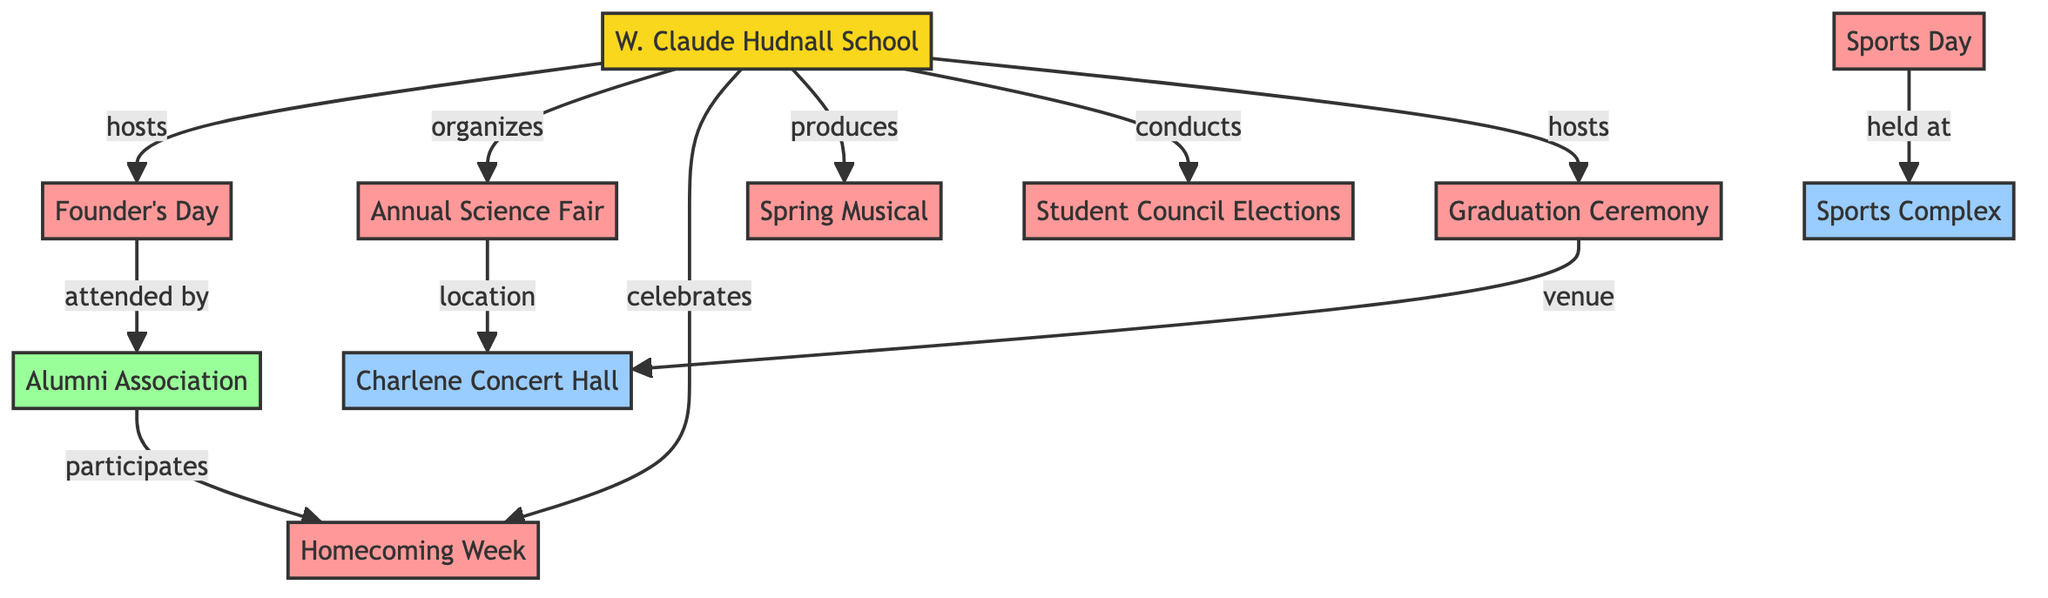What is the location of the Annual Science Fair? The Annual Science Fair is linked to Charlene Concert Hall by the "location" edge. Following this edge from node 3 (Annual Science Fair) leads to node 8 (Charlene Concert Hall)
Answer: Charlene Concert Hall Which event does W. Claude Hudnall School celebrate? The diagram shows a connection labeled "celebrates" from node 1 (W. Claude Hudnall School) to node 4 (Homecoming Week). This indicates that W. Claude Hudnall School celebrates Homecoming Week
Answer: Homecoming Week How many nodes are in the diagram? The diagram lists a total of 11 unique nodes representing different events, locations, and organizations. Counting each one gives us the total
Answer: 11 What type of event does the Alumni Association participate in? The Alumni Association participates in events that are linked to node 4 (Homecoming Week) by the "participates" edge from node 10 (Alumni Association)
Answer: Homecoming Week What is the connection type between Sports Day and Sports Complex? The relationship is defined by the edge labeled "held at," which connects node 6 (Sports Day) to node 9 (Sports Complex). This means Sports Day is held at the Sports Complex
Answer: held at Who attends Founder’s Day? There is an edge labeled "attended by" that connects node 2 (Founder’s Day) to node 10 (Alumni Association). This indicates that members of the Alumni Association attend Founder’s Day
Answer: Alumni Association Which event does W. Claude Hudnall School host besides Founder’s Day? Looking at the edges stemming from node 1 (W. Claude Hudnall School), the diagram shows it hosts both Founder’s Day and Graduation Ceremony. By checking other edges, we find that it also gets connected to node 11 (Graduation Ceremony)
Answer: Graduation Ceremony What events are produced by W. Claude Hudnall School? The diagram clearly indicates that W. Claude Hudnall School produces the Spring Musical, as per the connection labeled "produces" from node 1 to node 5
Answer: Spring Musical 